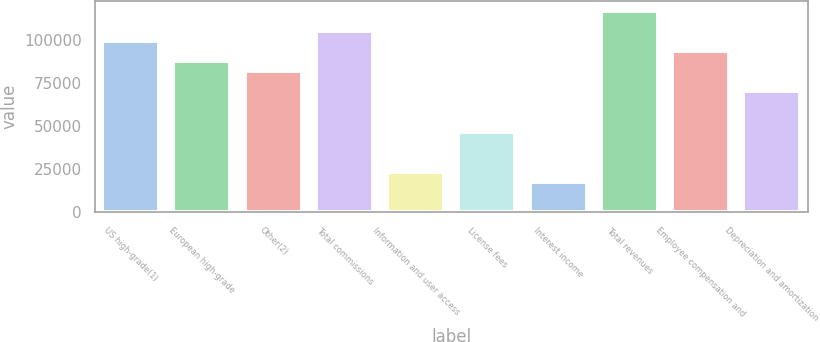Convert chart. <chart><loc_0><loc_0><loc_500><loc_500><bar_chart><fcel>US high-grade(1)<fcel>European high-grade<fcel>Other(2)<fcel>Total commissions<fcel>Information and user access<fcel>License fees<fcel>Interest income<fcel>Total revenues<fcel>Employee compensation and<fcel>Depreciation and amortization<nl><fcel>99380.5<fcel>87688.9<fcel>81843.1<fcel>105226<fcel>23385.3<fcel>46768.4<fcel>17539.5<fcel>116918<fcel>93534.7<fcel>70151.6<nl></chart> 